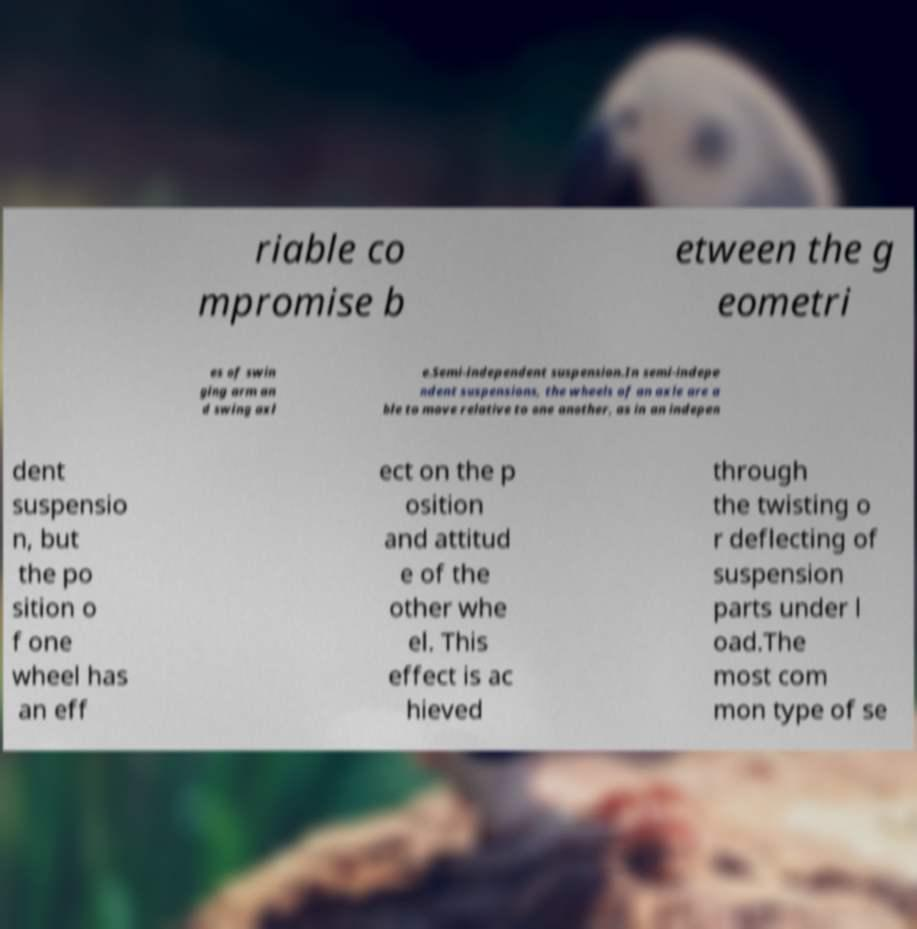For documentation purposes, I need the text within this image transcribed. Could you provide that? riable co mpromise b etween the g eometri es of swin ging arm an d swing axl e.Semi-independent suspension.In semi-indepe ndent suspensions, the wheels of an axle are a ble to move relative to one another, as in an indepen dent suspensio n, but the po sition o f one wheel has an eff ect on the p osition and attitud e of the other whe el. This effect is ac hieved through the twisting o r deflecting of suspension parts under l oad.The most com mon type of se 